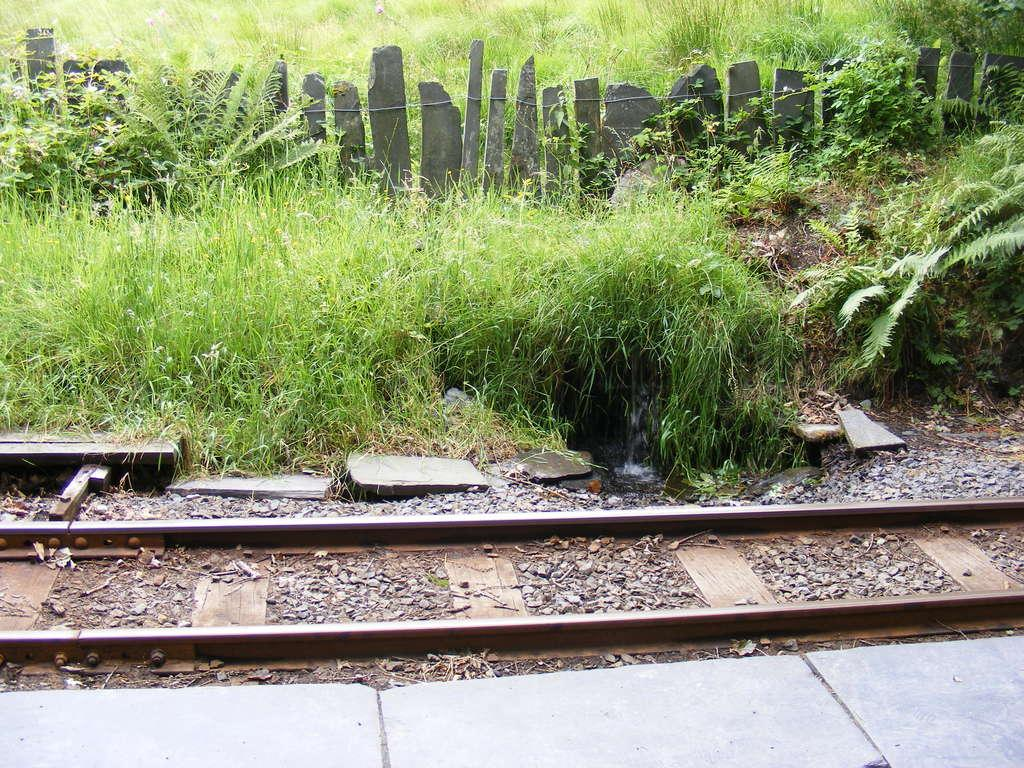What is on the ground in the image? There is a railway track on the ground. What else can be seen near the railway track? There are stones and plants/grass near the track. Can you describe the ground in the image? The ground is visible in the image. What is at the top of the image? There is a fence at the top of the image. What suggestion is being made by the railway track in the image? The railway track is not making any suggestions in the image; it is an inanimate object. 